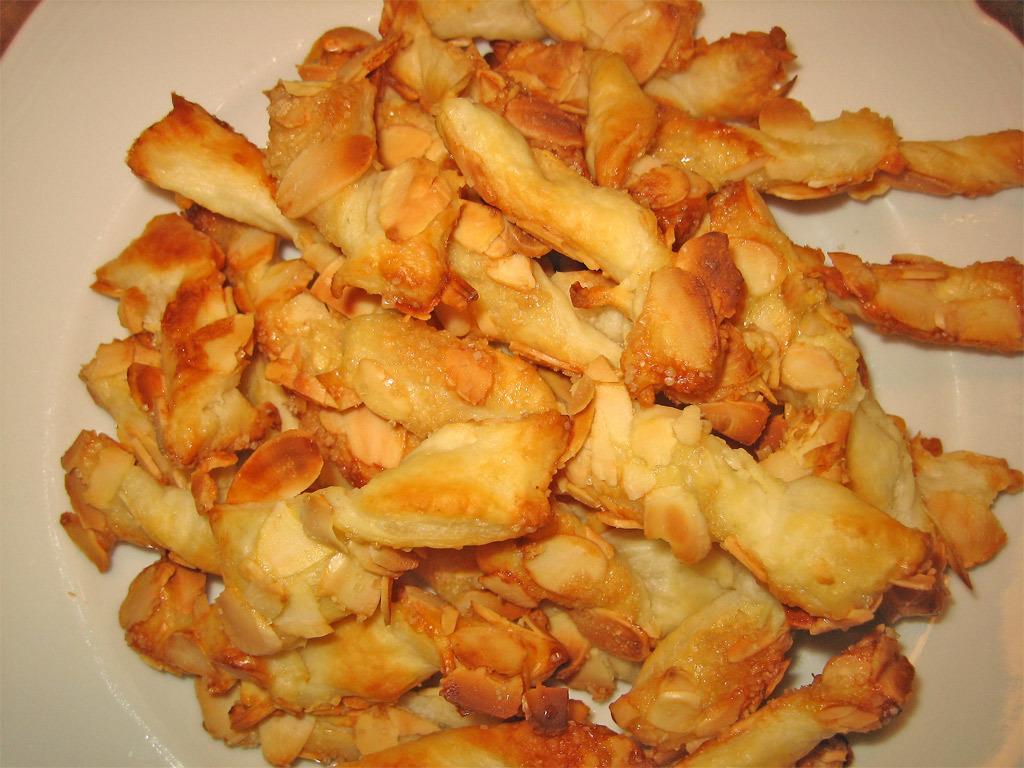Can you describe this image briefly? This image consists of food which is in the center on the plate which is white in colour. 